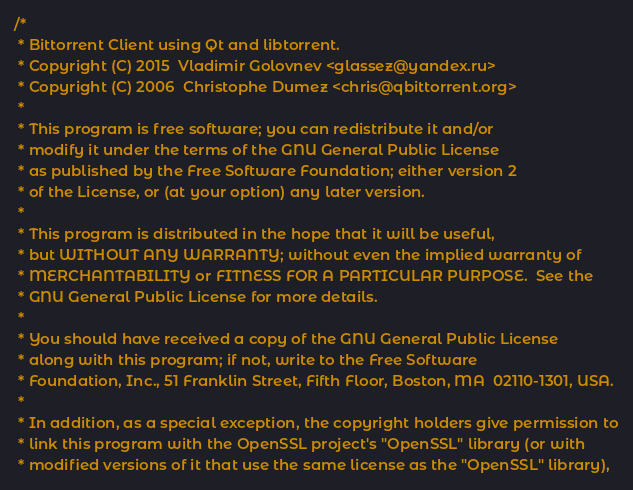<code> <loc_0><loc_0><loc_500><loc_500><_C++_>/*
 * Bittorrent Client using Qt and libtorrent.
 * Copyright (C) 2015  Vladimir Golovnev <glassez@yandex.ru>
 * Copyright (C) 2006  Christophe Dumez <chris@qbittorrent.org>
 *
 * This program is free software; you can redistribute it and/or
 * modify it under the terms of the GNU General Public License
 * as published by the Free Software Foundation; either version 2
 * of the License, or (at your option) any later version.
 *
 * This program is distributed in the hope that it will be useful,
 * but WITHOUT ANY WARRANTY; without even the implied warranty of
 * MERCHANTABILITY or FITNESS FOR A PARTICULAR PURPOSE.  See the
 * GNU General Public License for more details.
 *
 * You should have received a copy of the GNU General Public License
 * along with this program; if not, write to the Free Software
 * Foundation, Inc., 51 Franklin Street, Fifth Floor, Boston, MA  02110-1301, USA.
 *
 * In addition, as a special exception, the copyright holders give permission to
 * link this program with the OpenSSL project's "OpenSSL" library (or with
 * modified versions of it that use the same license as the "OpenSSL" library),</code> 